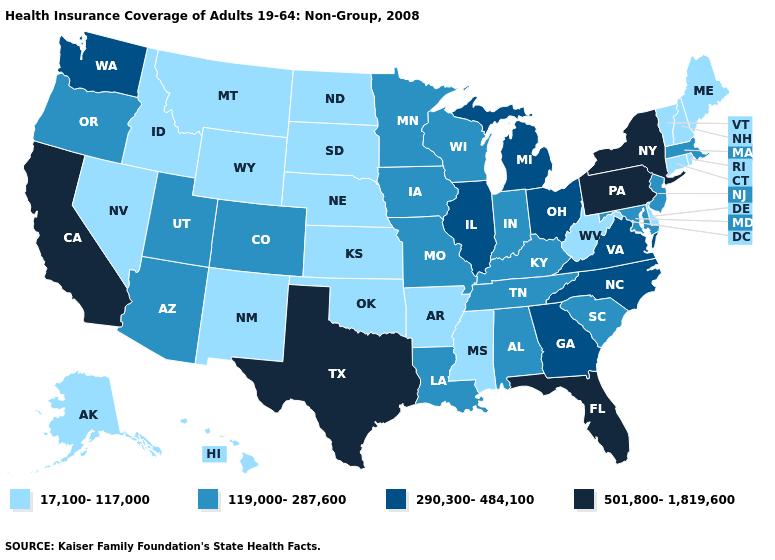What is the value of Massachusetts?
Short answer required. 119,000-287,600. How many symbols are there in the legend?
Answer briefly. 4. Does New Jersey have a higher value than Louisiana?
Be succinct. No. Among the states that border Nebraska , does Missouri have the lowest value?
Write a very short answer. No. What is the value of Nebraska?
Answer briefly. 17,100-117,000. What is the value of Hawaii?
Quick response, please. 17,100-117,000. Name the states that have a value in the range 290,300-484,100?
Be succinct. Georgia, Illinois, Michigan, North Carolina, Ohio, Virginia, Washington. Which states have the highest value in the USA?
Be succinct. California, Florida, New York, Pennsylvania, Texas. Name the states that have a value in the range 119,000-287,600?
Short answer required. Alabama, Arizona, Colorado, Indiana, Iowa, Kentucky, Louisiana, Maryland, Massachusetts, Minnesota, Missouri, New Jersey, Oregon, South Carolina, Tennessee, Utah, Wisconsin. What is the value of Virginia?
Give a very brief answer. 290,300-484,100. Among the states that border Texas , which have the lowest value?
Answer briefly. Arkansas, New Mexico, Oklahoma. Which states have the lowest value in the Northeast?
Write a very short answer. Connecticut, Maine, New Hampshire, Rhode Island, Vermont. How many symbols are there in the legend?
Keep it brief. 4. Name the states that have a value in the range 17,100-117,000?
Concise answer only. Alaska, Arkansas, Connecticut, Delaware, Hawaii, Idaho, Kansas, Maine, Mississippi, Montana, Nebraska, Nevada, New Hampshire, New Mexico, North Dakota, Oklahoma, Rhode Island, South Dakota, Vermont, West Virginia, Wyoming. What is the value of Wyoming?
Write a very short answer. 17,100-117,000. 